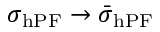<formula> <loc_0><loc_0><loc_500><loc_500>\sigma _ { h P F } \rightarrow \bar { \sigma } _ { h P F }</formula> 